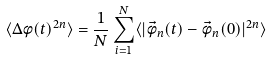<formula> <loc_0><loc_0><loc_500><loc_500>\langle \Delta \phi ( t ) ^ { 2 n } \rangle = \frac { 1 } { N } \sum _ { i = 1 } ^ { N } \langle | \vec { \phi } _ { n } ( t ) - \vec { \phi } _ { n } ( 0 ) | ^ { 2 n } \rangle</formula> 